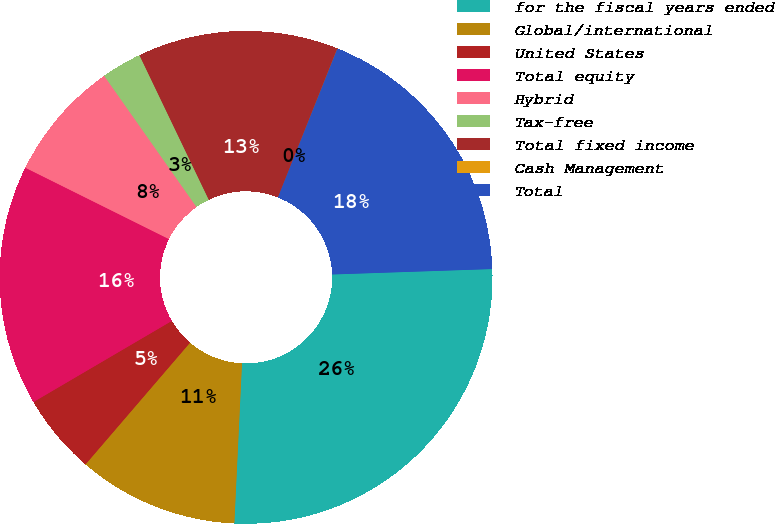<chart> <loc_0><loc_0><loc_500><loc_500><pie_chart><fcel>for the fiscal years ended<fcel>Global/international<fcel>United States<fcel>Total equity<fcel>Hybrid<fcel>Tax-free<fcel>Total fixed income<fcel>Cash Management<fcel>Total<nl><fcel>26.3%<fcel>10.53%<fcel>5.27%<fcel>15.78%<fcel>7.9%<fcel>2.64%<fcel>13.16%<fcel>0.01%<fcel>18.41%<nl></chart> 